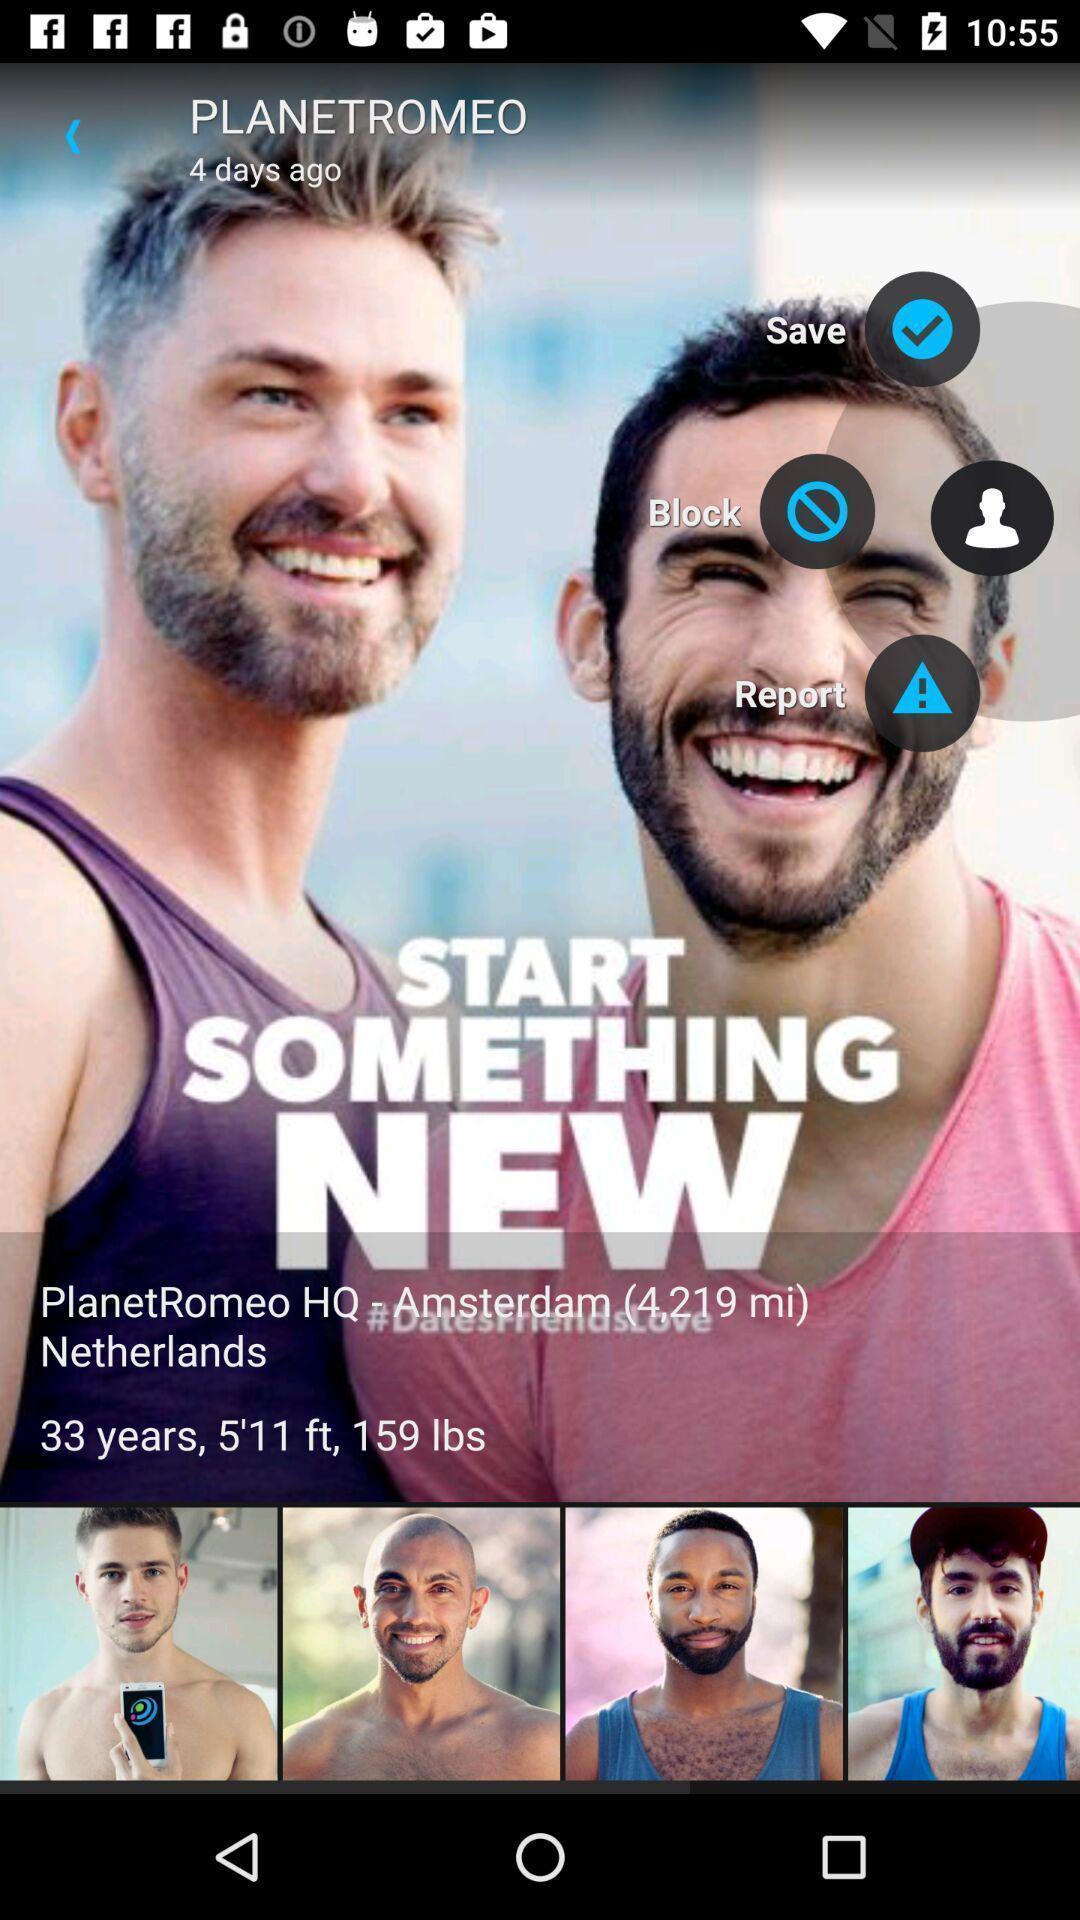Provide a description of this screenshot. Welcome page displaying of an dating application. 